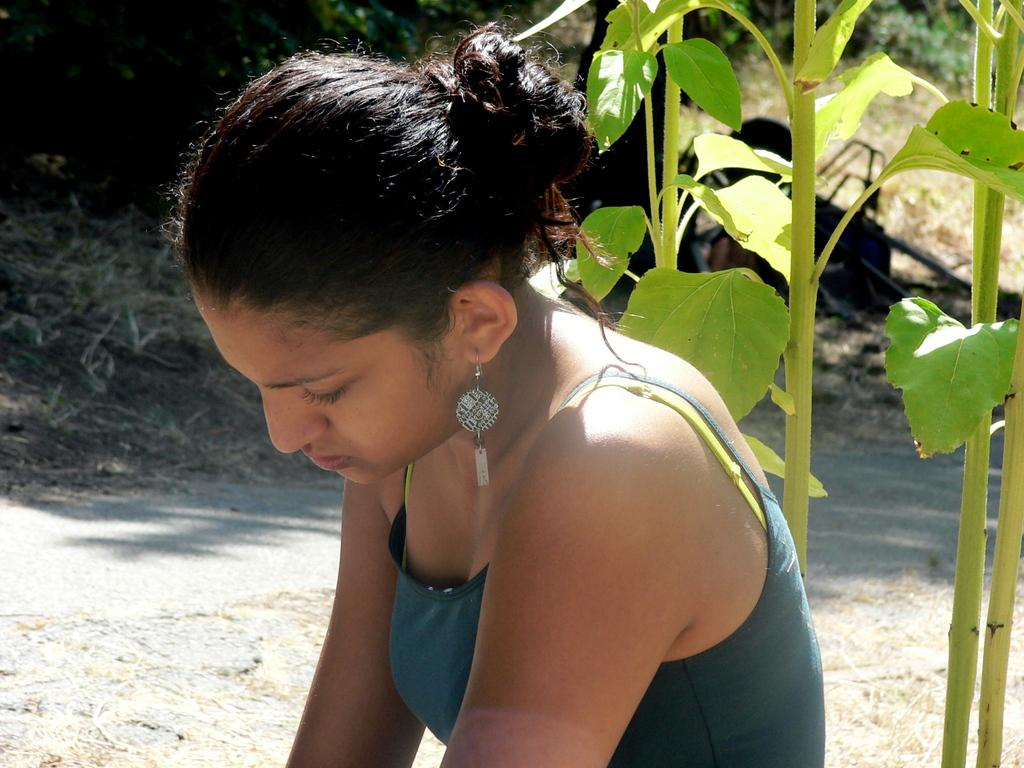Who is the main subject in the image? There is a woman in the image. What can be seen behind the woman? There are plants behind the woman. What type of ground is visible in the background? There is grass on the ground in the background. Can you describe any other objects or features in the background? There is an unspecified object and additional plants in the background. What type of ornament is the queen wearing on her veil in the image? There is no queen, veil, or ornament present in the image. 